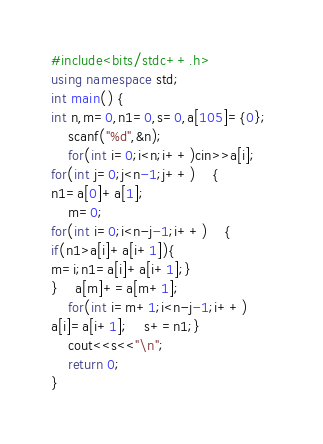<code> <loc_0><loc_0><loc_500><loc_500><_C++_>#include<bits/stdc++.h> 
using namespace std; 
int main() { 	
int n,m=0,n1=0,s=0,a[105]={0}; 
	scanf("%d",&n); 
	for(int i=0;i<n;i++)cin>>a[i]; 	
for(int j=0;j<n-1;j++) 	{
n1=a[0]+a[1]; 
	m=0; 	
for(int i=0;i<n-j-1;i++) 	{
if(n1>a[i]+a[i+1]){
m=i;n1=a[i]+a[i+1];}
} 	a[m]+=a[m+1]; 
	for(int i=m+1;i<n-j-1;i++)
a[i]=a[i+1]; 	s+=n1;} 
	cout<<s<<"\n"; 
	return 0; 
}
</code> 